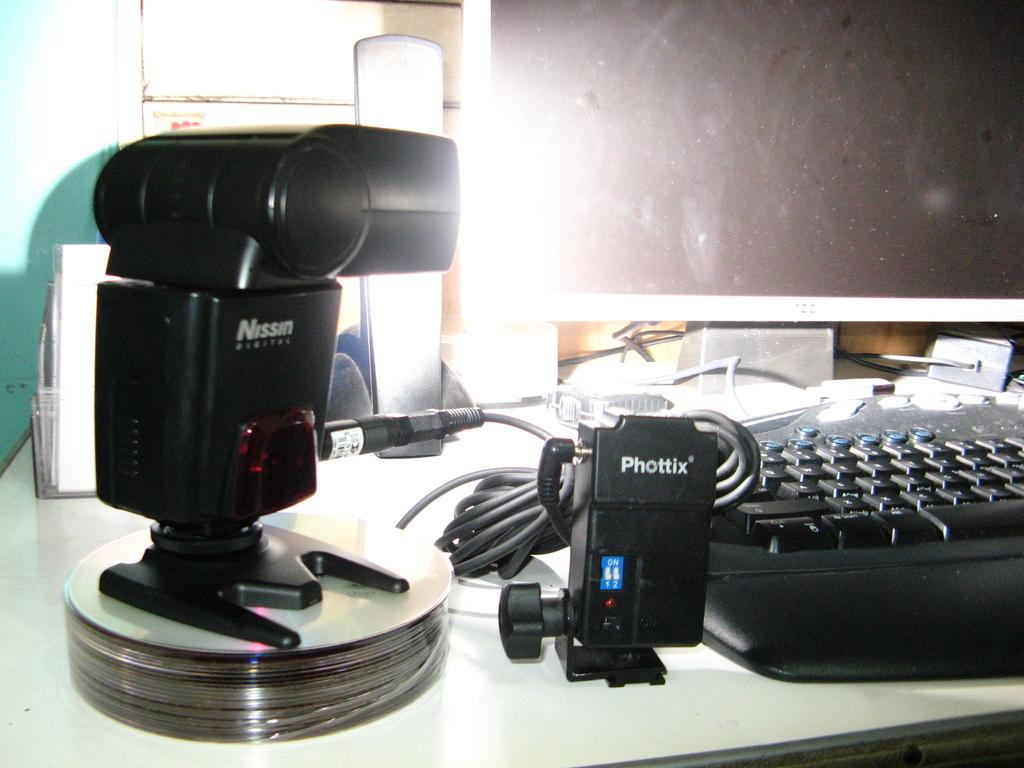<image>
Relay a brief, clear account of the picture shown. a camera that is labeled 'nissin digital' in white on it 